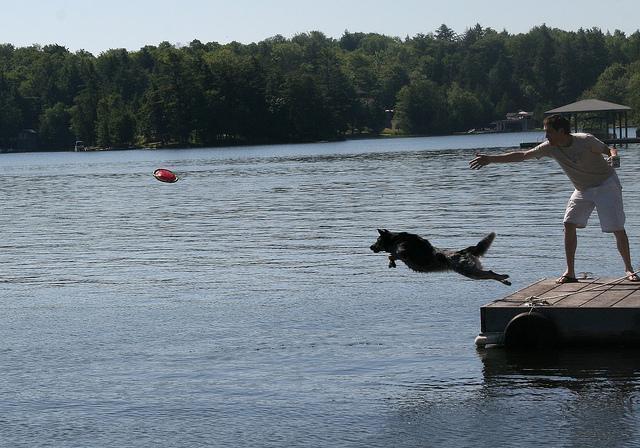How many oranges are in the basket?
Give a very brief answer. 0. 